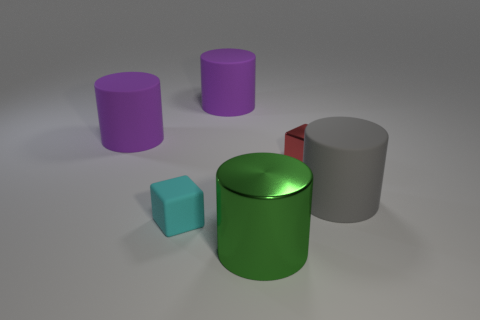Subtract all big green metal cylinders. How many cylinders are left? 3 Subtract 2 cylinders. How many cylinders are left? 2 Subtract all gray cylinders. How many cylinders are left? 3 Subtract all cyan cylinders. Subtract all brown balls. How many cylinders are left? 4 Add 2 large purple spheres. How many objects exist? 8 Subtract all cylinders. How many objects are left? 2 Subtract 0 yellow blocks. How many objects are left? 6 Subtract all tiny red metallic objects. Subtract all small cyan rubber things. How many objects are left? 4 Add 1 rubber things. How many rubber things are left? 5 Add 4 big brown matte cylinders. How many big brown matte cylinders exist? 4 